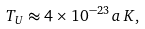<formula> <loc_0><loc_0><loc_500><loc_500>T _ { U } \approx 4 \times 1 0 ^ { - 2 3 } \, a \, K ,</formula> 